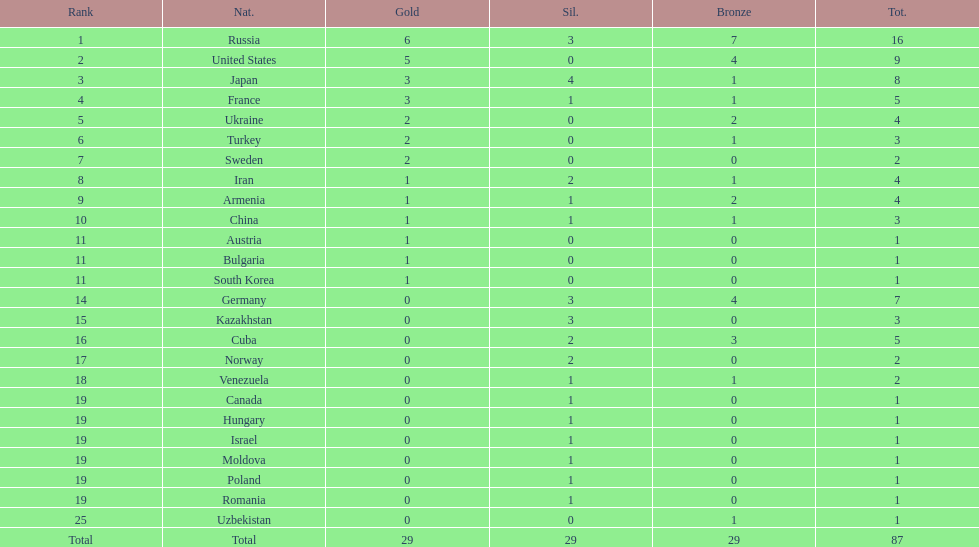What is the total amount of nations with more than 5 bronze medals? 1. 